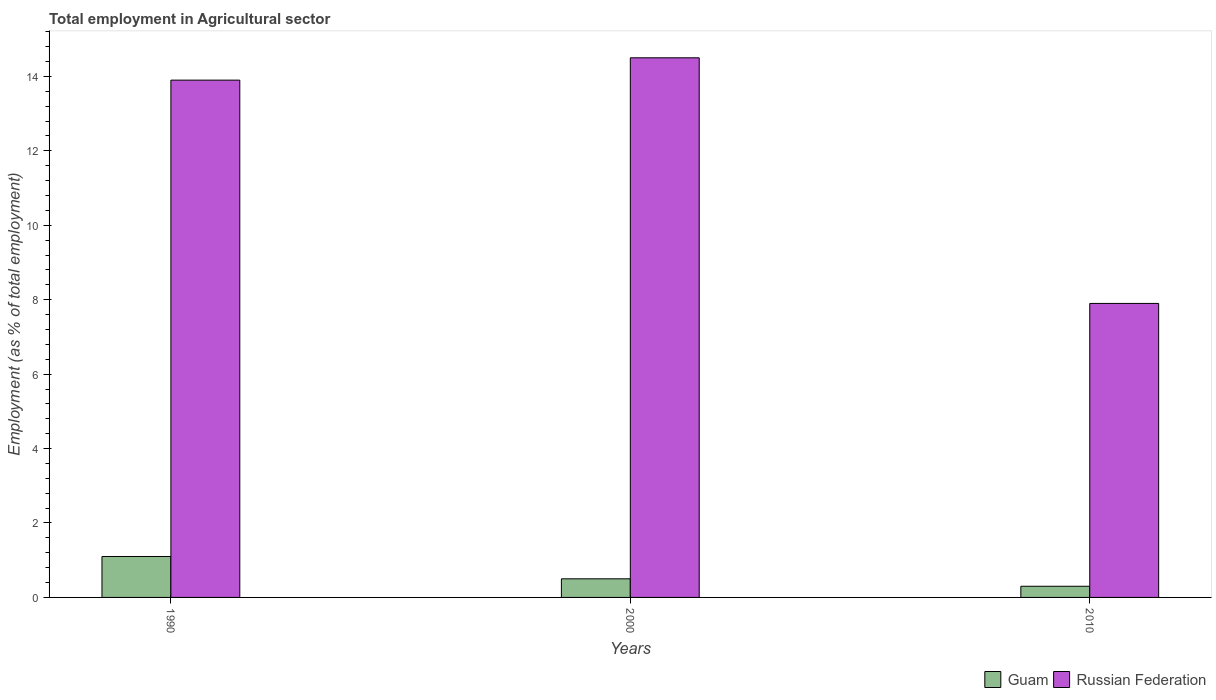How many different coloured bars are there?
Your answer should be compact. 2. Are the number of bars on each tick of the X-axis equal?
Offer a very short reply. Yes. How many bars are there on the 1st tick from the left?
Give a very brief answer. 2. How many bars are there on the 2nd tick from the right?
Make the answer very short. 2. What is the label of the 3rd group of bars from the left?
Keep it short and to the point. 2010. What is the employment in agricultural sector in Guam in 1990?
Provide a short and direct response. 1.1. Across all years, what is the maximum employment in agricultural sector in Guam?
Keep it short and to the point. 1.1. Across all years, what is the minimum employment in agricultural sector in Guam?
Your response must be concise. 0.3. In which year was the employment in agricultural sector in Russian Federation minimum?
Your response must be concise. 2010. What is the total employment in agricultural sector in Guam in the graph?
Provide a succinct answer. 1.9. What is the difference between the employment in agricultural sector in Russian Federation in 2000 and that in 2010?
Keep it short and to the point. 6.6. What is the difference between the employment in agricultural sector in Russian Federation in 2000 and the employment in agricultural sector in Guam in 1990?
Offer a very short reply. 13.4. What is the average employment in agricultural sector in Guam per year?
Make the answer very short. 0.63. In the year 2010, what is the difference between the employment in agricultural sector in Russian Federation and employment in agricultural sector in Guam?
Offer a very short reply. 7.6. In how many years, is the employment in agricultural sector in Russian Federation greater than 0.4 %?
Provide a succinct answer. 3. What is the ratio of the employment in agricultural sector in Guam in 1990 to that in 2010?
Your answer should be very brief. 3.67. Is the employment in agricultural sector in Guam in 2000 less than that in 2010?
Offer a very short reply. No. Is the difference between the employment in agricultural sector in Russian Federation in 2000 and 2010 greater than the difference between the employment in agricultural sector in Guam in 2000 and 2010?
Ensure brevity in your answer.  Yes. What is the difference between the highest and the second highest employment in agricultural sector in Guam?
Keep it short and to the point. 0.6. What is the difference between the highest and the lowest employment in agricultural sector in Russian Federation?
Your answer should be compact. 6.6. Is the sum of the employment in agricultural sector in Guam in 1990 and 2000 greater than the maximum employment in agricultural sector in Russian Federation across all years?
Keep it short and to the point. No. What does the 2nd bar from the left in 2010 represents?
Give a very brief answer. Russian Federation. What does the 2nd bar from the right in 1990 represents?
Your response must be concise. Guam. What is the difference between two consecutive major ticks on the Y-axis?
Offer a very short reply. 2. Are the values on the major ticks of Y-axis written in scientific E-notation?
Offer a terse response. No. How are the legend labels stacked?
Provide a succinct answer. Horizontal. What is the title of the graph?
Make the answer very short. Total employment in Agricultural sector. Does "Iran" appear as one of the legend labels in the graph?
Offer a terse response. No. What is the label or title of the X-axis?
Your response must be concise. Years. What is the label or title of the Y-axis?
Ensure brevity in your answer.  Employment (as % of total employment). What is the Employment (as % of total employment) in Guam in 1990?
Your answer should be very brief. 1.1. What is the Employment (as % of total employment) in Russian Federation in 1990?
Your answer should be compact. 13.9. What is the Employment (as % of total employment) of Guam in 2000?
Offer a very short reply. 0.5. What is the Employment (as % of total employment) in Russian Federation in 2000?
Make the answer very short. 14.5. What is the Employment (as % of total employment) in Guam in 2010?
Your response must be concise. 0.3. What is the Employment (as % of total employment) in Russian Federation in 2010?
Give a very brief answer. 7.9. Across all years, what is the maximum Employment (as % of total employment) in Guam?
Your response must be concise. 1.1. Across all years, what is the minimum Employment (as % of total employment) in Guam?
Provide a short and direct response. 0.3. Across all years, what is the minimum Employment (as % of total employment) of Russian Federation?
Your response must be concise. 7.9. What is the total Employment (as % of total employment) in Russian Federation in the graph?
Your response must be concise. 36.3. What is the difference between the Employment (as % of total employment) of Guam in 1990 and that in 2000?
Keep it short and to the point. 0.6. What is the difference between the Employment (as % of total employment) in Guam in 1990 and that in 2010?
Offer a terse response. 0.8. What is the difference between the Employment (as % of total employment) of Russian Federation in 1990 and that in 2010?
Offer a very short reply. 6. What is the difference between the Employment (as % of total employment) of Guam in 1990 and the Employment (as % of total employment) of Russian Federation in 2010?
Keep it short and to the point. -6.8. What is the average Employment (as % of total employment) of Guam per year?
Your answer should be compact. 0.63. What is the average Employment (as % of total employment) in Russian Federation per year?
Your answer should be compact. 12.1. In the year 1990, what is the difference between the Employment (as % of total employment) of Guam and Employment (as % of total employment) of Russian Federation?
Give a very brief answer. -12.8. What is the ratio of the Employment (as % of total employment) of Guam in 1990 to that in 2000?
Ensure brevity in your answer.  2.2. What is the ratio of the Employment (as % of total employment) of Russian Federation in 1990 to that in 2000?
Offer a terse response. 0.96. What is the ratio of the Employment (as % of total employment) in Guam in 1990 to that in 2010?
Your answer should be compact. 3.67. What is the ratio of the Employment (as % of total employment) of Russian Federation in 1990 to that in 2010?
Provide a short and direct response. 1.76. What is the ratio of the Employment (as % of total employment) in Guam in 2000 to that in 2010?
Make the answer very short. 1.67. What is the ratio of the Employment (as % of total employment) of Russian Federation in 2000 to that in 2010?
Provide a short and direct response. 1.84. What is the difference between the highest and the second highest Employment (as % of total employment) in Russian Federation?
Your answer should be very brief. 0.6. What is the difference between the highest and the lowest Employment (as % of total employment) of Guam?
Offer a terse response. 0.8. 